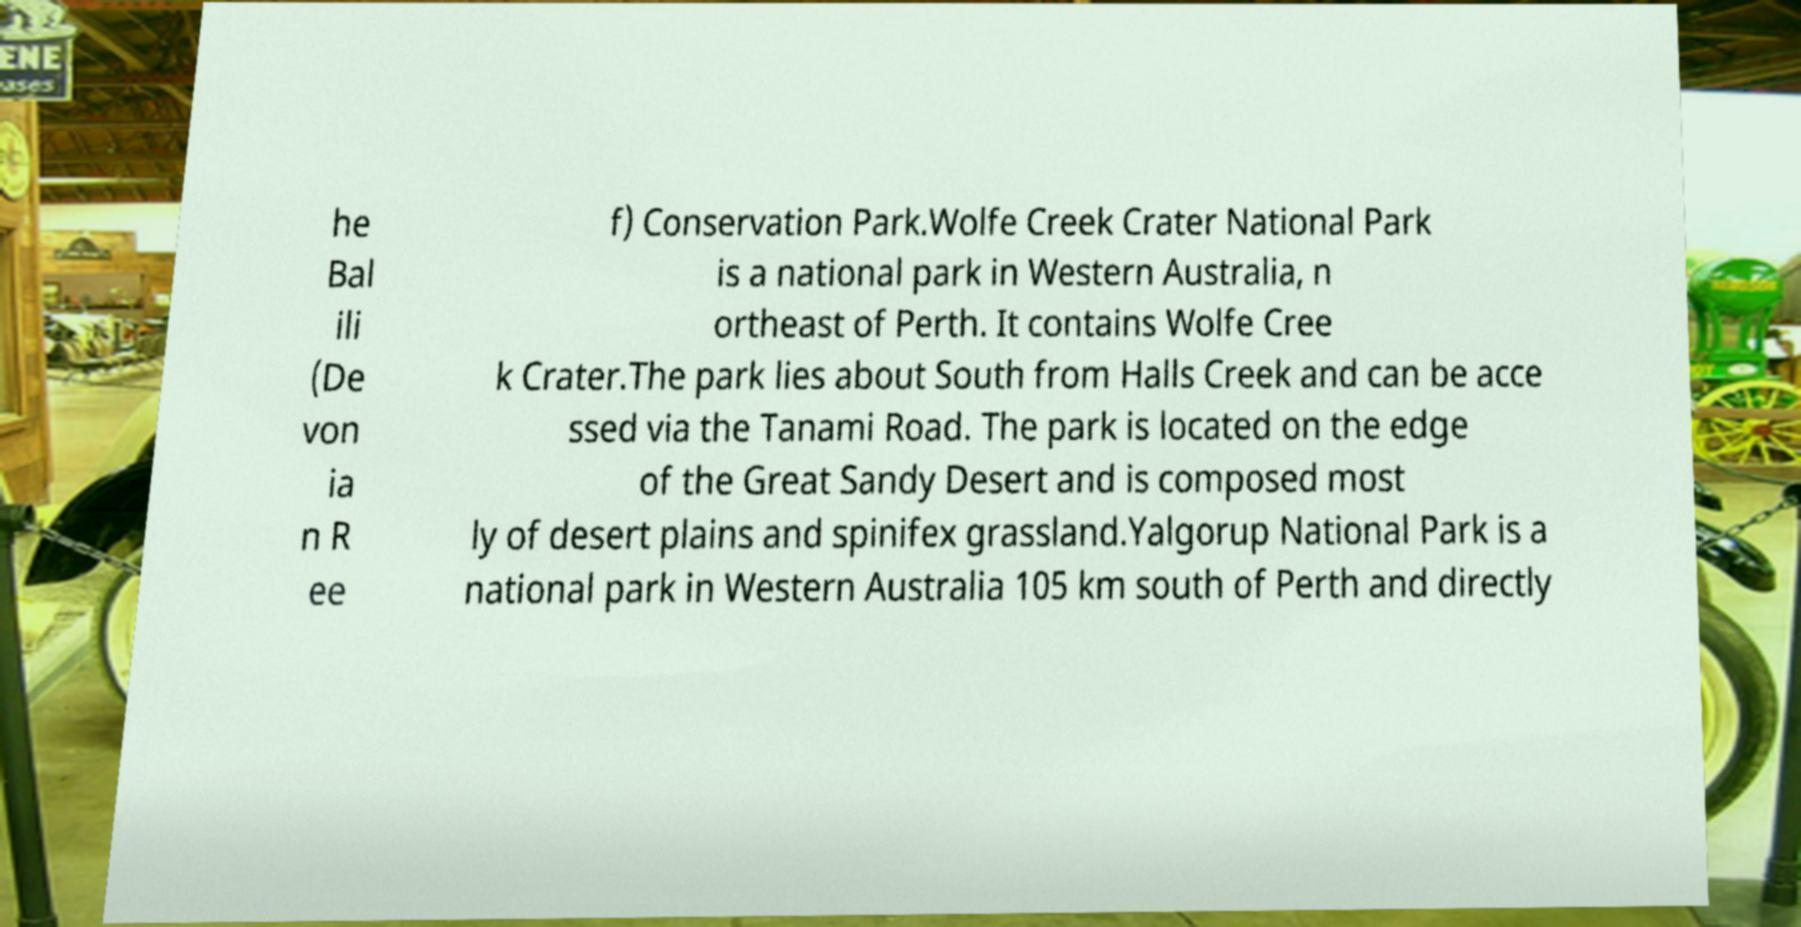Can you read and provide the text displayed in the image?This photo seems to have some interesting text. Can you extract and type it out for me? he Bal ili (De von ia n R ee f) Conservation Park.Wolfe Creek Crater National Park is a national park in Western Australia, n ortheast of Perth. It contains Wolfe Cree k Crater.The park lies about South from Halls Creek and can be acce ssed via the Tanami Road. The park is located on the edge of the Great Sandy Desert and is composed most ly of desert plains and spinifex grassland.Yalgorup National Park is a national park in Western Australia 105 km south of Perth and directly 